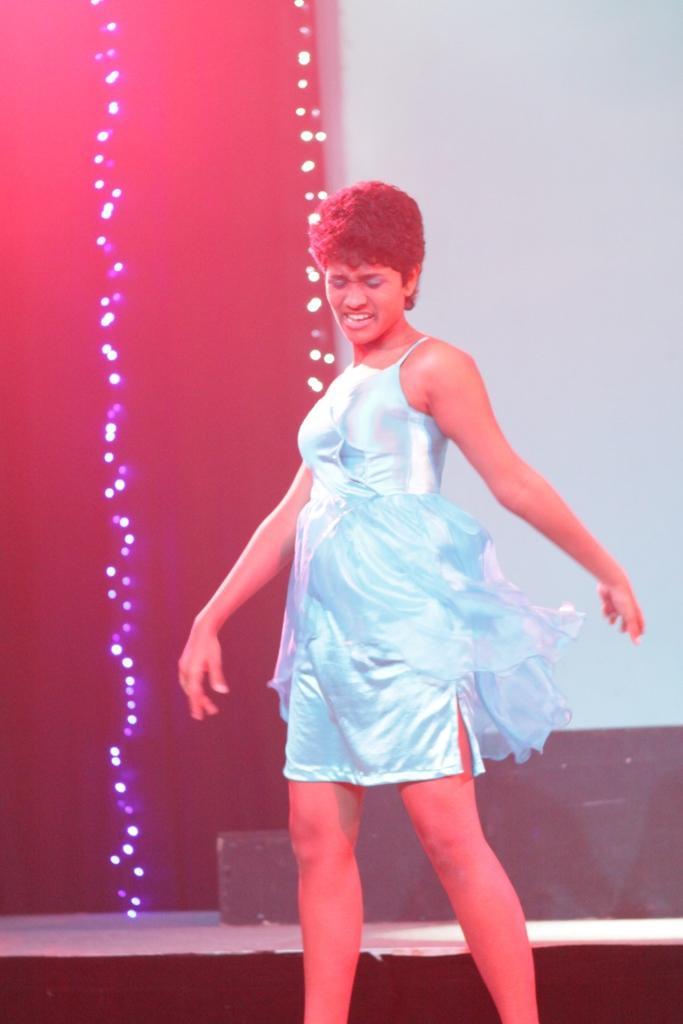Please provide a concise description of this image. Here I can see a woman standing. It seems like she is dancing on the stage. In the background, I can see few lights. 